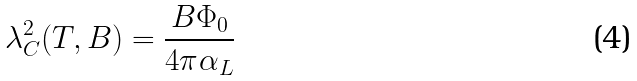Convert formula to latex. <formula><loc_0><loc_0><loc_500><loc_500>\lambda _ { C } ^ { 2 } ( T , B ) = \frac { B \Phi _ { 0 } } { 4 \pi \alpha _ { L } }</formula> 